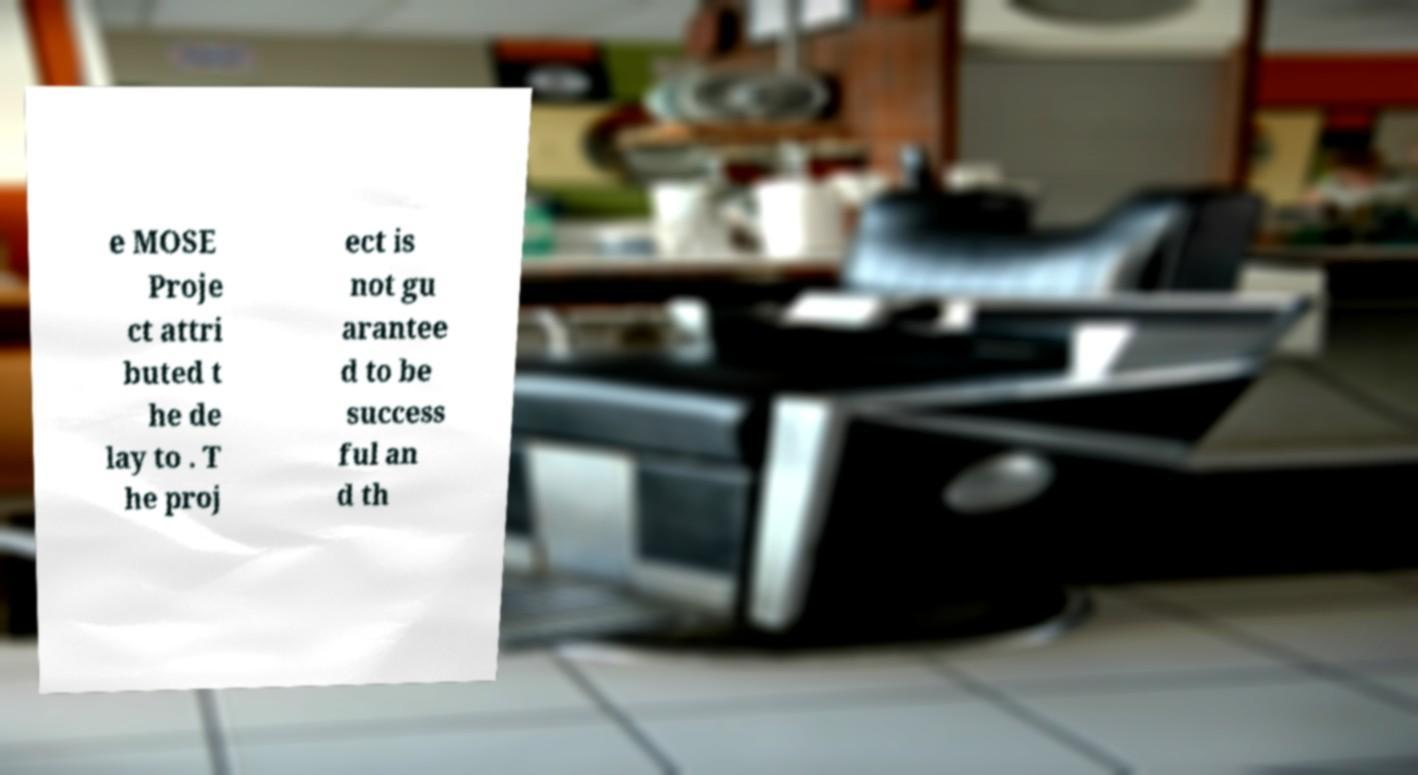Can you read and provide the text displayed in the image?This photo seems to have some interesting text. Can you extract and type it out for me? e MOSE Proje ct attri buted t he de lay to . T he proj ect is not gu arantee d to be success ful an d th 